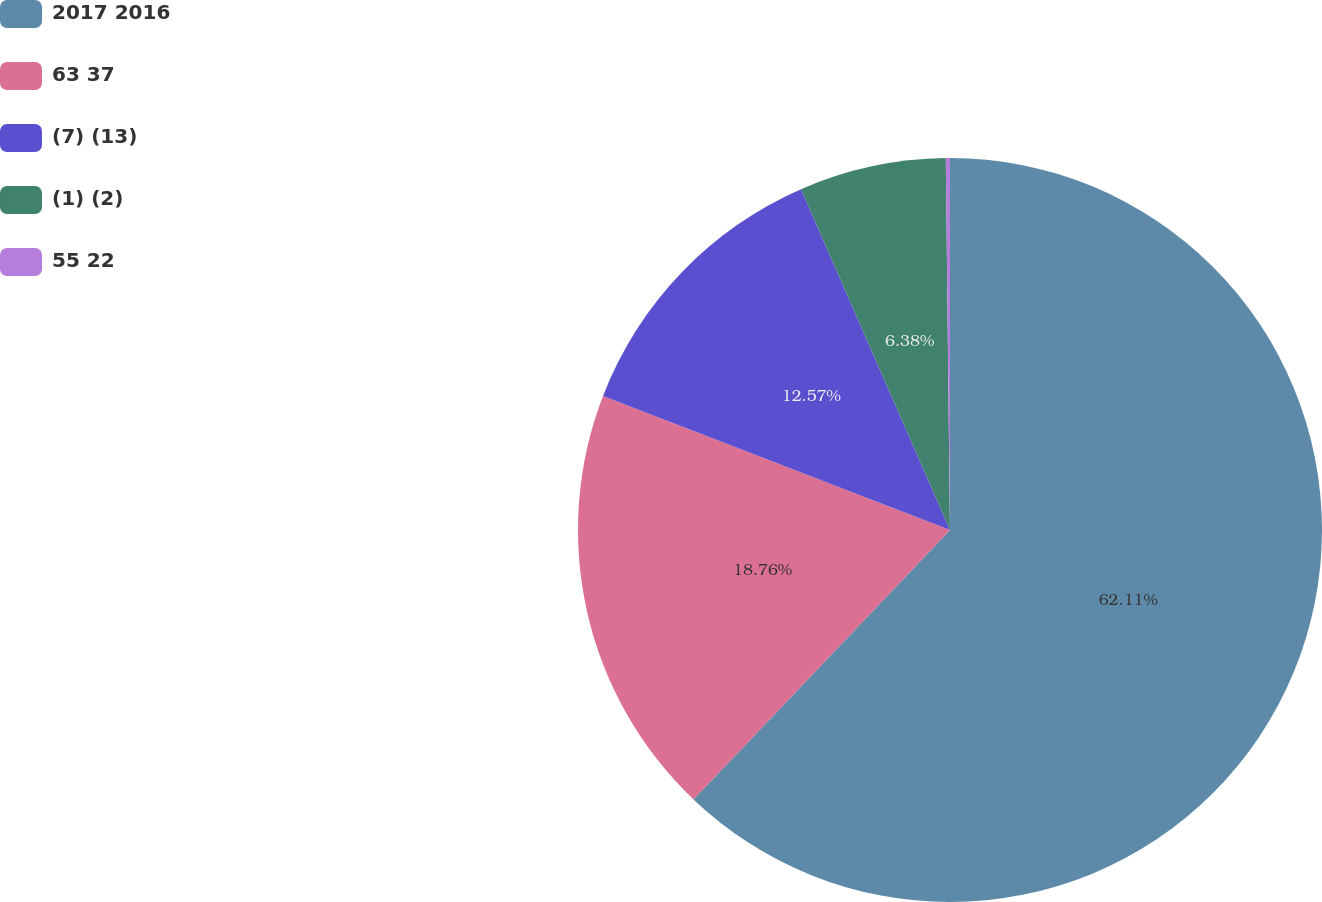<chart> <loc_0><loc_0><loc_500><loc_500><pie_chart><fcel>2017 2016<fcel>63 37<fcel>(7) (13)<fcel>(1) (2)<fcel>55 22<nl><fcel>62.11%<fcel>18.76%<fcel>12.57%<fcel>6.38%<fcel>0.18%<nl></chart> 